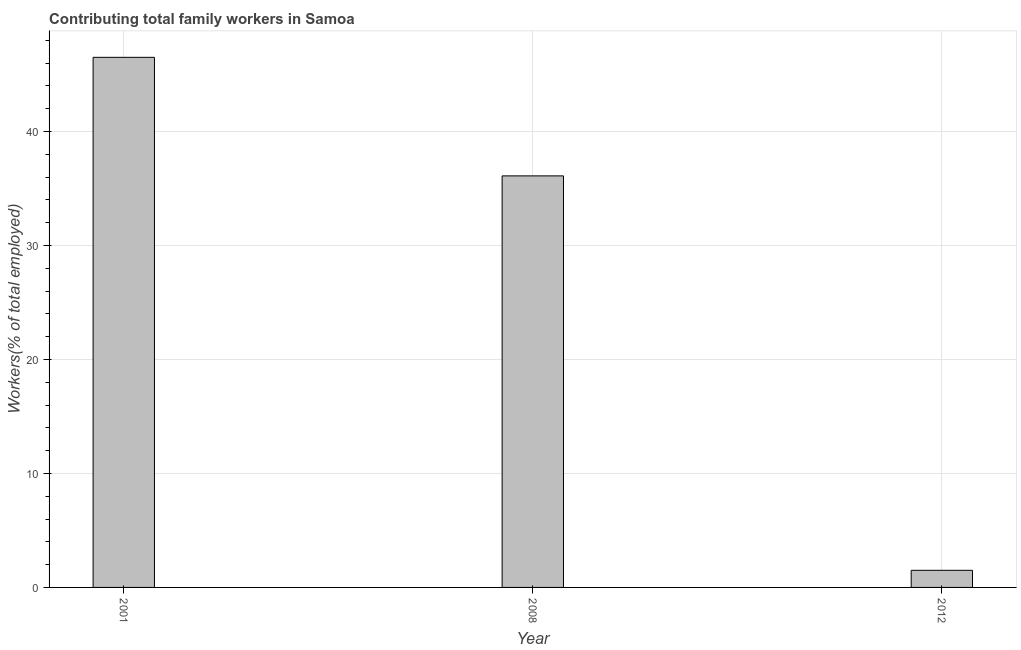Does the graph contain any zero values?
Provide a short and direct response. No. What is the title of the graph?
Your answer should be very brief. Contributing total family workers in Samoa. What is the label or title of the Y-axis?
Give a very brief answer. Workers(% of total employed). What is the contributing family workers in 2001?
Your response must be concise. 46.5. Across all years, what is the maximum contributing family workers?
Give a very brief answer. 46.5. In which year was the contributing family workers minimum?
Your answer should be very brief. 2012. What is the sum of the contributing family workers?
Your answer should be very brief. 84.1. What is the average contributing family workers per year?
Ensure brevity in your answer.  28.03. What is the median contributing family workers?
Offer a very short reply. 36.1. Do a majority of the years between 2001 and 2012 (inclusive) have contributing family workers greater than 40 %?
Your answer should be very brief. No. Is the contributing family workers in 2001 less than that in 2008?
Your answer should be compact. No. Is the difference between the contributing family workers in 2008 and 2012 greater than the difference between any two years?
Your answer should be very brief. No. Is the sum of the contributing family workers in 2008 and 2012 greater than the maximum contributing family workers across all years?
Offer a very short reply. No. What is the difference between the highest and the lowest contributing family workers?
Make the answer very short. 45. Are all the bars in the graph horizontal?
Provide a short and direct response. No. How many years are there in the graph?
Your answer should be very brief. 3. Are the values on the major ticks of Y-axis written in scientific E-notation?
Give a very brief answer. No. What is the Workers(% of total employed) of 2001?
Your answer should be compact. 46.5. What is the Workers(% of total employed) of 2008?
Offer a very short reply. 36.1. What is the Workers(% of total employed) of 2012?
Offer a terse response. 1.5. What is the difference between the Workers(% of total employed) in 2001 and 2008?
Offer a very short reply. 10.4. What is the difference between the Workers(% of total employed) in 2001 and 2012?
Your answer should be very brief. 45. What is the difference between the Workers(% of total employed) in 2008 and 2012?
Your answer should be very brief. 34.6. What is the ratio of the Workers(% of total employed) in 2001 to that in 2008?
Provide a succinct answer. 1.29. What is the ratio of the Workers(% of total employed) in 2001 to that in 2012?
Provide a short and direct response. 31. What is the ratio of the Workers(% of total employed) in 2008 to that in 2012?
Offer a terse response. 24.07. 